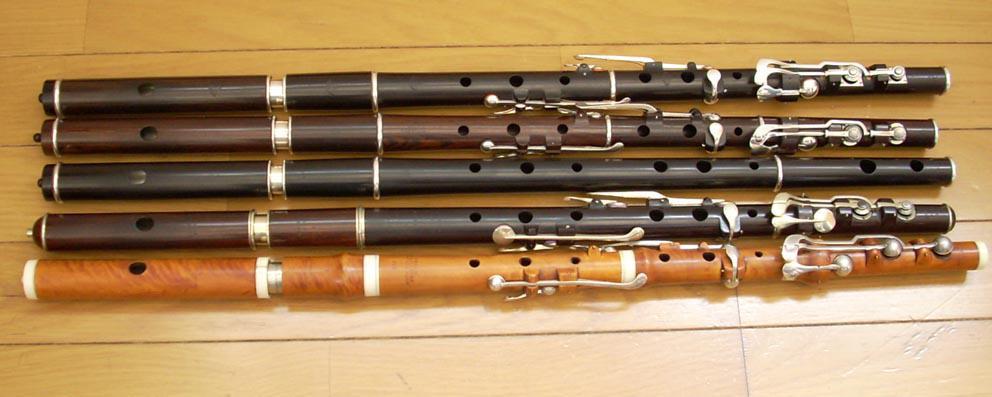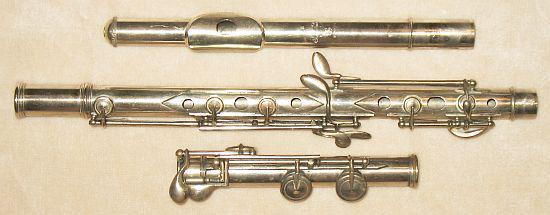The first image is the image on the left, the second image is the image on the right. For the images displayed, is the sentence "In the image on the right, a brown and black case contains at least 2 sections of a flute." factually correct? Answer yes or no. No. The first image is the image on the left, the second image is the image on the right. Examine the images to the left and right. Is the description "The right image features an open case and instrument parts that are not connected, and the left image includes multiple items displayed horizontally but not touching." accurate? Answer yes or no. No. 